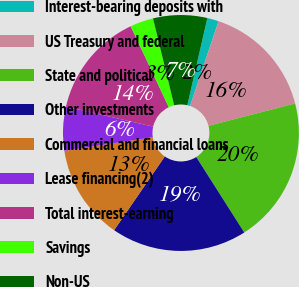Convert chart to OTSL. <chart><loc_0><loc_0><loc_500><loc_500><pie_chart><fcel>Interest-bearing deposits with<fcel>US Treasury and federal<fcel>State and political<fcel>Other investments<fcel>Commercial and financial loans<fcel>Lease financing(2)<fcel>Total interest-earning<fcel>Savings<fcel>Non-US<nl><fcel>1.57%<fcel>15.81%<fcel>20.01%<fcel>18.61%<fcel>13.0%<fcel>6.0%<fcel>14.41%<fcel>3.2%<fcel>7.4%<nl></chart> 